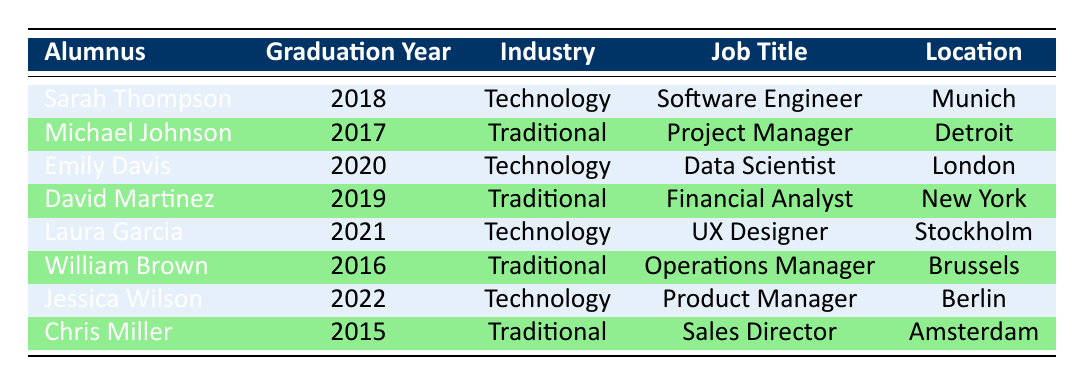What is the job title of Sarah Thompson? The table shows that Sarah Thompson is listed under the Technology industry, and her job title is listed right next to her name, which is Software Engineer.
Answer: Software Engineer How many alumni work in the Traditional industry? By counting the rows where the current industry is listed as Traditional, we find Michael Johnson, David Martinez, William Brown, and Chris Miller, totaling four individuals in the Traditional industry.
Answer: 4 What is the graduation year of Laura Garcia? In the table, Laura Garcia's name is located, and directly to the right in the graduation year column, it specifies 2021 as her graduation year.
Answer: 2021 Are there any alumni listed in the table who work at Amazon? Looking at the company names under the Technology industry, Jessica Wilson is listed as working for Amazon. Therefore, it confirms the presence of an alumnus who works at this company.
Answer: Yes Which industry has more alumni, Technology or Traditional? There are four alumni in the Traditional industry (Michael Johnson, David Martinez, William Brown, and Chris Miller) and three alumni in the Technology industry (Sarah Thompson, Emily Davis, and Laura Garcia). Comparing the numbers shows Traditional has more alumni.
Answer: Traditional What is the job title of the alumni located in Brussels? The table shows that William Brown is listed as an Operations Manager and is located in Brussels, so he is the alumnus corresponding to that location and job title.
Answer: Operations Manager Which alumnus graduated most recently and what is their job title? The most recent graduation year in the table is 2022, which corresponds to Jessica Wilson. Looking at her job title, she is a Product Manager as per her listing in the Technology industry.
Answer: Product Manager How many alumni are located in Germany? By observing the table, both Sarah Thompson (in Munich) and Jessica Wilson (in Berlin) are noted as being located in Germany, amounting to two alumni in that country.
Answer: 2 What would be the difference in the graduation years of the most recent and the oldest alumnus listed? The most recent graduate is Jessica Wilson from 2022, and the oldest graduate is Chris Miller from 2015. The difference is calculated as 2022 - 2015, which equals 7 years.
Answer: 7 